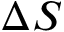<formula> <loc_0><loc_0><loc_500><loc_500>\Delta S</formula> 